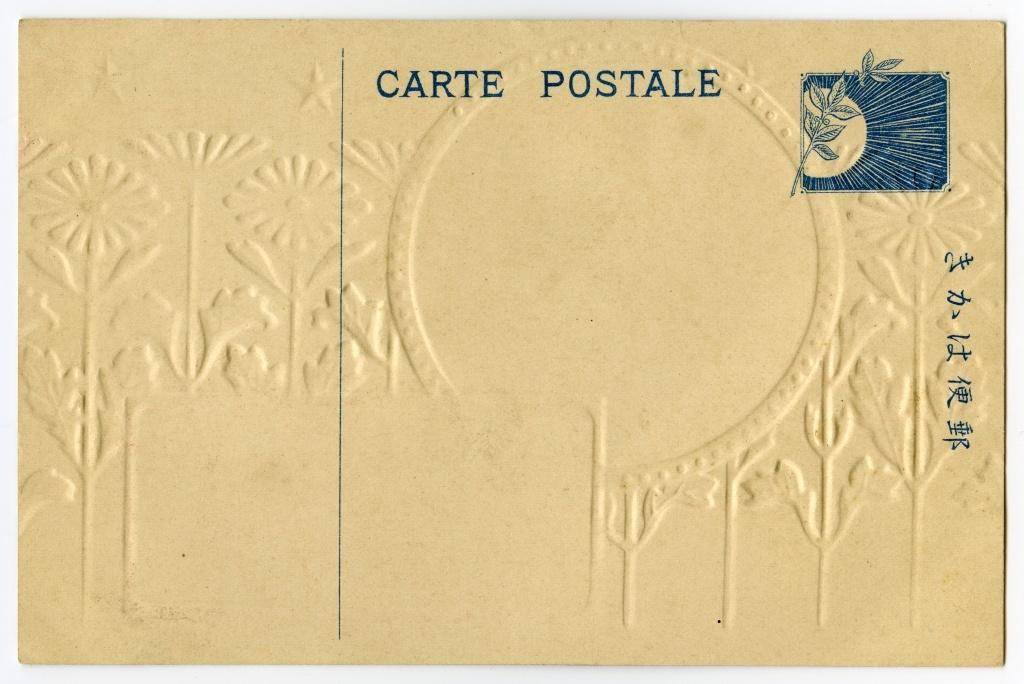Provide a one-sentence caption for the provided image. The white Carte Postale postcard has some flower etching in the background. 